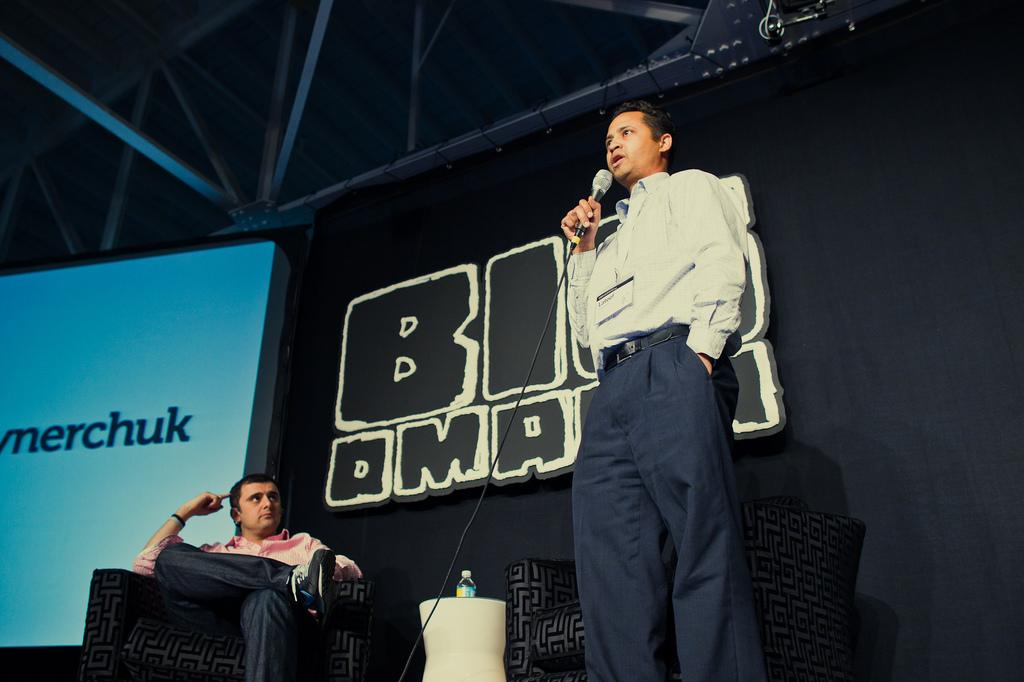What is the man in the image holding? The man is holding a microphone. What is the position of the other man in the image? The other man is sitting on a chair in the image. How many chairs are visible in the image? There are chairs in the image in the image. What can be seen in the background of the image? There is a screen, a board, and rods in the background of the image. What language is being spoken by the man holding the microphone in the image? The provided facts do not mention any specific language being spoken in the image, so we cannot determine the language being spoken. Is this image taken in an office setting? The provided facts do not mention any specific location or setting for the image, so we cannot determine if it is an office or not. 